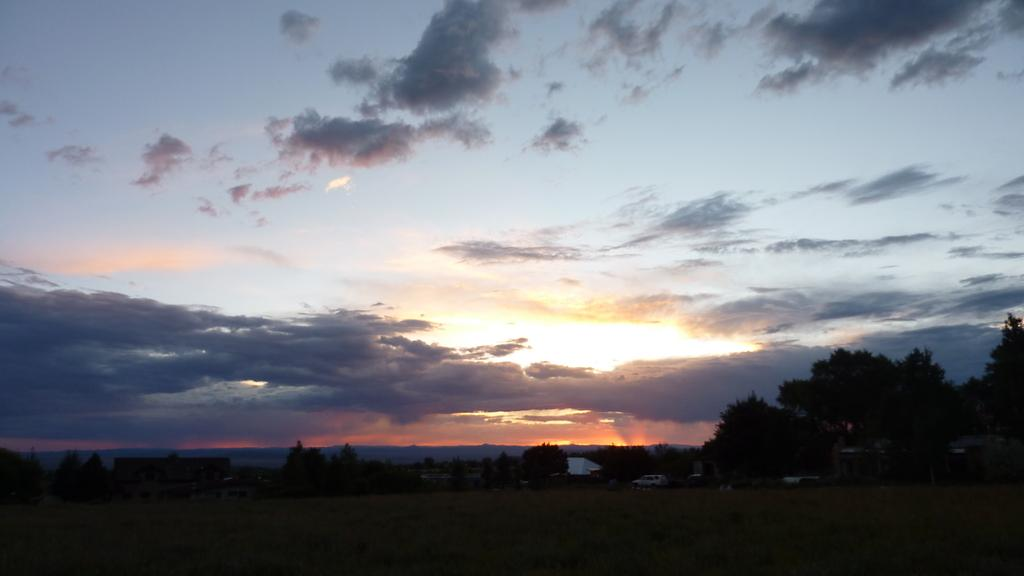What type of natural elements can be seen in the image? There are trees in the image. What type of man-made structures are present in the image? There are buildings in the image. What type of transportation can be seen on the ground in the image? There are vehicles on the ground in the image. What is visible in the sky in the image? There are clouds in the sky in the image. What time of day is depicted in the image? The image depicts a sunset. Can you see any kites flying in the image? There are no kites visible in the image. What type of error is present in the image? There is no error present in the image. 